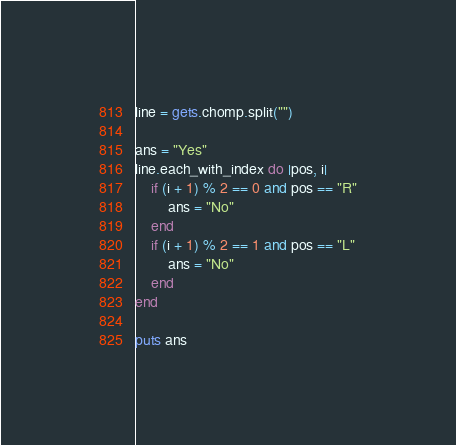Convert code to text. <code><loc_0><loc_0><loc_500><loc_500><_Ruby_>line = gets.chomp.split("")

ans = "Yes"
line.each_with_index do |pos, i|
    if (i + 1) % 2 == 0 and pos == "R"
        ans = "No"
    end
    if (i + 1) % 2 == 1 and pos == "L"
        ans = "No"
    end
end

puts ans
</code> 